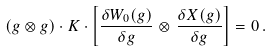Convert formula to latex. <formula><loc_0><loc_0><loc_500><loc_500>( g \otimes g ) \cdot K \cdot \left [ \frac { \delta W _ { 0 } ( g ) } { \delta g } \otimes \, \frac { \delta X ( g ) } { \delta g } \right ] = 0 \, .</formula> 